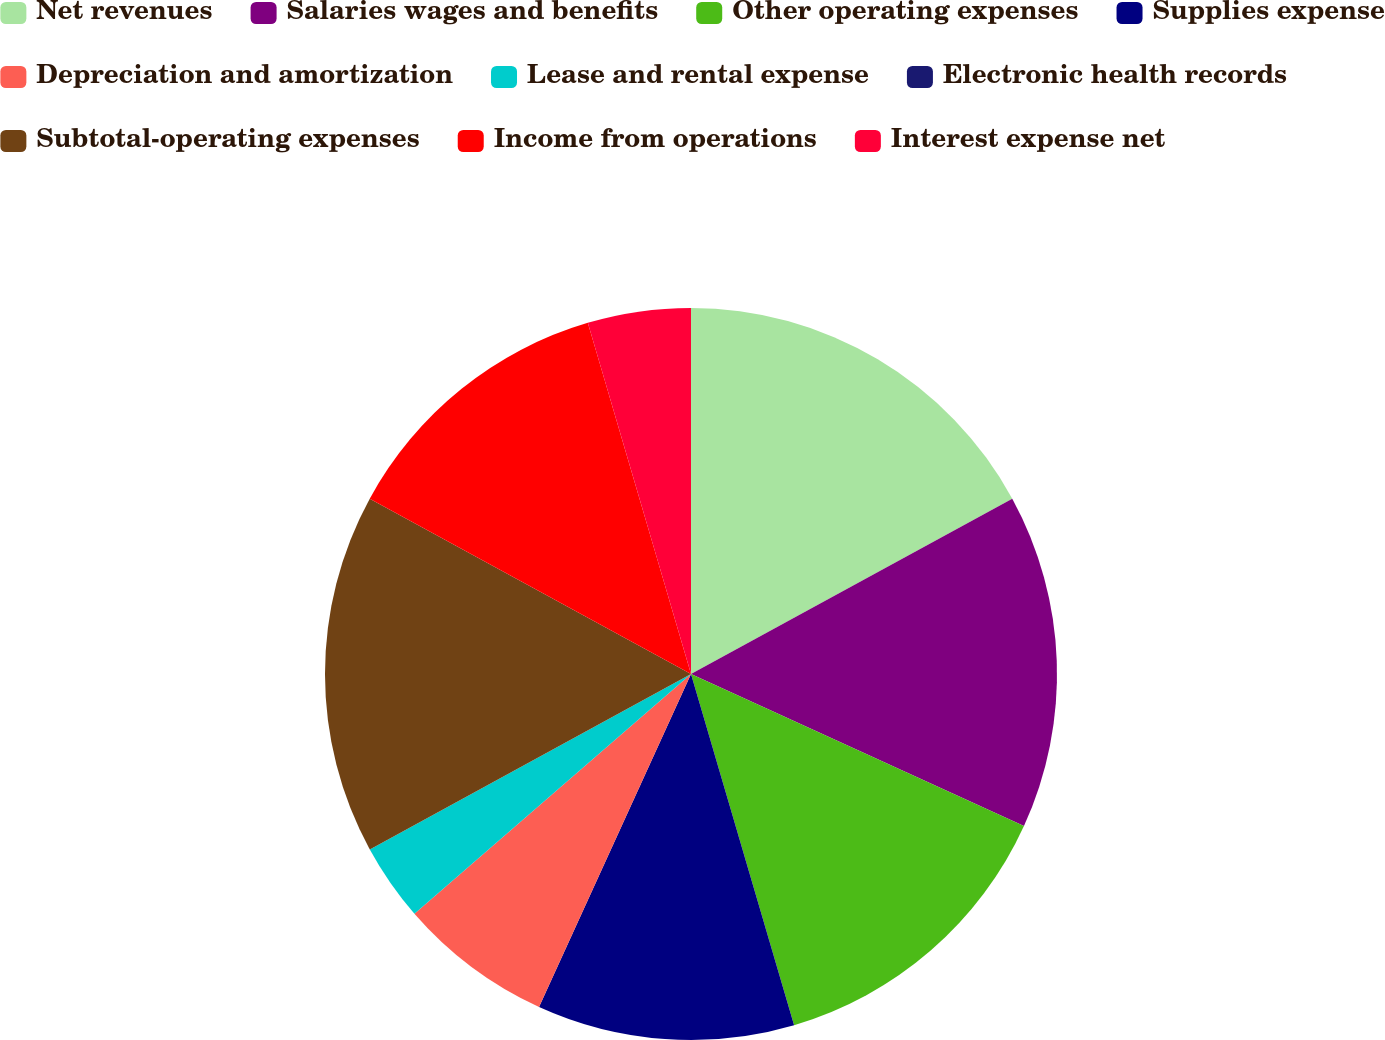<chart> <loc_0><loc_0><loc_500><loc_500><pie_chart><fcel>Net revenues<fcel>Salaries wages and benefits<fcel>Other operating expenses<fcel>Supplies expense<fcel>Depreciation and amortization<fcel>Lease and rental expense<fcel>Electronic health records<fcel>Subtotal-operating expenses<fcel>Income from operations<fcel>Interest expense net<nl><fcel>17.05%<fcel>14.77%<fcel>13.64%<fcel>11.36%<fcel>6.82%<fcel>3.41%<fcel>0.0%<fcel>15.91%<fcel>12.5%<fcel>4.55%<nl></chart> 